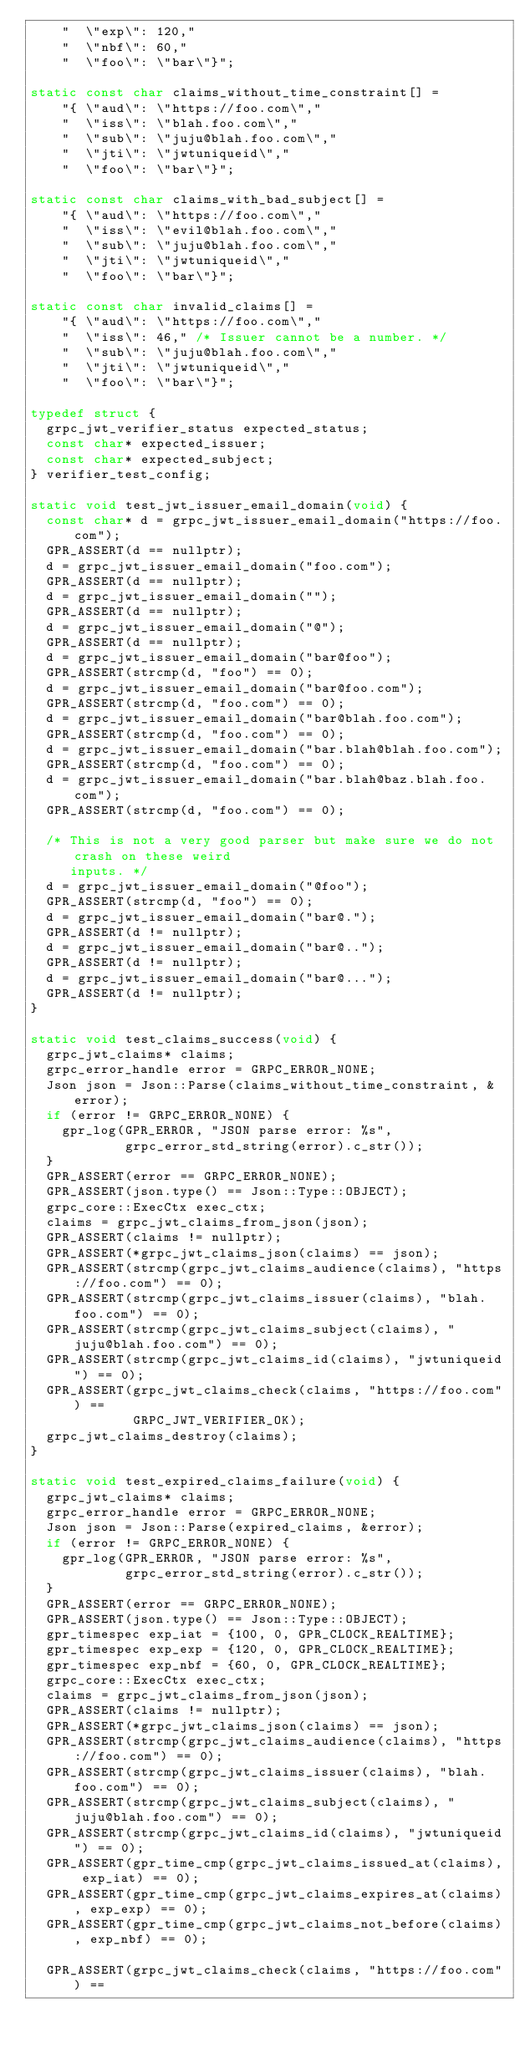<code> <loc_0><loc_0><loc_500><loc_500><_C++_>    "  \"exp\": 120,"
    "  \"nbf\": 60,"
    "  \"foo\": \"bar\"}";

static const char claims_without_time_constraint[] =
    "{ \"aud\": \"https://foo.com\","
    "  \"iss\": \"blah.foo.com\","
    "  \"sub\": \"juju@blah.foo.com\","
    "  \"jti\": \"jwtuniqueid\","
    "  \"foo\": \"bar\"}";

static const char claims_with_bad_subject[] =
    "{ \"aud\": \"https://foo.com\","
    "  \"iss\": \"evil@blah.foo.com\","
    "  \"sub\": \"juju@blah.foo.com\","
    "  \"jti\": \"jwtuniqueid\","
    "  \"foo\": \"bar\"}";

static const char invalid_claims[] =
    "{ \"aud\": \"https://foo.com\","
    "  \"iss\": 46," /* Issuer cannot be a number. */
    "  \"sub\": \"juju@blah.foo.com\","
    "  \"jti\": \"jwtuniqueid\","
    "  \"foo\": \"bar\"}";

typedef struct {
  grpc_jwt_verifier_status expected_status;
  const char* expected_issuer;
  const char* expected_subject;
} verifier_test_config;

static void test_jwt_issuer_email_domain(void) {
  const char* d = grpc_jwt_issuer_email_domain("https://foo.com");
  GPR_ASSERT(d == nullptr);
  d = grpc_jwt_issuer_email_domain("foo.com");
  GPR_ASSERT(d == nullptr);
  d = grpc_jwt_issuer_email_domain("");
  GPR_ASSERT(d == nullptr);
  d = grpc_jwt_issuer_email_domain("@");
  GPR_ASSERT(d == nullptr);
  d = grpc_jwt_issuer_email_domain("bar@foo");
  GPR_ASSERT(strcmp(d, "foo") == 0);
  d = grpc_jwt_issuer_email_domain("bar@foo.com");
  GPR_ASSERT(strcmp(d, "foo.com") == 0);
  d = grpc_jwt_issuer_email_domain("bar@blah.foo.com");
  GPR_ASSERT(strcmp(d, "foo.com") == 0);
  d = grpc_jwt_issuer_email_domain("bar.blah@blah.foo.com");
  GPR_ASSERT(strcmp(d, "foo.com") == 0);
  d = grpc_jwt_issuer_email_domain("bar.blah@baz.blah.foo.com");
  GPR_ASSERT(strcmp(d, "foo.com") == 0);

  /* This is not a very good parser but make sure we do not crash on these weird
     inputs. */
  d = grpc_jwt_issuer_email_domain("@foo");
  GPR_ASSERT(strcmp(d, "foo") == 0);
  d = grpc_jwt_issuer_email_domain("bar@.");
  GPR_ASSERT(d != nullptr);
  d = grpc_jwt_issuer_email_domain("bar@..");
  GPR_ASSERT(d != nullptr);
  d = grpc_jwt_issuer_email_domain("bar@...");
  GPR_ASSERT(d != nullptr);
}

static void test_claims_success(void) {
  grpc_jwt_claims* claims;
  grpc_error_handle error = GRPC_ERROR_NONE;
  Json json = Json::Parse(claims_without_time_constraint, &error);
  if (error != GRPC_ERROR_NONE) {
    gpr_log(GPR_ERROR, "JSON parse error: %s",
            grpc_error_std_string(error).c_str());
  }
  GPR_ASSERT(error == GRPC_ERROR_NONE);
  GPR_ASSERT(json.type() == Json::Type::OBJECT);
  grpc_core::ExecCtx exec_ctx;
  claims = grpc_jwt_claims_from_json(json);
  GPR_ASSERT(claims != nullptr);
  GPR_ASSERT(*grpc_jwt_claims_json(claims) == json);
  GPR_ASSERT(strcmp(grpc_jwt_claims_audience(claims), "https://foo.com") == 0);
  GPR_ASSERT(strcmp(grpc_jwt_claims_issuer(claims), "blah.foo.com") == 0);
  GPR_ASSERT(strcmp(grpc_jwt_claims_subject(claims), "juju@blah.foo.com") == 0);
  GPR_ASSERT(strcmp(grpc_jwt_claims_id(claims), "jwtuniqueid") == 0);
  GPR_ASSERT(grpc_jwt_claims_check(claims, "https://foo.com") ==
             GRPC_JWT_VERIFIER_OK);
  grpc_jwt_claims_destroy(claims);
}

static void test_expired_claims_failure(void) {
  grpc_jwt_claims* claims;
  grpc_error_handle error = GRPC_ERROR_NONE;
  Json json = Json::Parse(expired_claims, &error);
  if (error != GRPC_ERROR_NONE) {
    gpr_log(GPR_ERROR, "JSON parse error: %s",
            grpc_error_std_string(error).c_str());
  }
  GPR_ASSERT(error == GRPC_ERROR_NONE);
  GPR_ASSERT(json.type() == Json::Type::OBJECT);
  gpr_timespec exp_iat = {100, 0, GPR_CLOCK_REALTIME};
  gpr_timespec exp_exp = {120, 0, GPR_CLOCK_REALTIME};
  gpr_timespec exp_nbf = {60, 0, GPR_CLOCK_REALTIME};
  grpc_core::ExecCtx exec_ctx;
  claims = grpc_jwt_claims_from_json(json);
  GPR_ASSERT(claims != nullptr);
  GPR_ASSERT(*grpc_jwt_claims_json(claims) == json);
  GPR_ASSERT(strcmp(grpc_jwt_claims_audience(claims), "https://foo.com") == 0);
  GPR_ASSERT(strcmp(grpc_jwt_claims_issuer(claims), "blah.foo.com") == 0);
  GPR_ASSERT(strcmp(grpc_jwt_claims_subject(claims), "juju@blah.foo.com") == 0);
  GPR_ASSERT(strcmp(grpc_jwt_claims_id(claims), "jwtuniqueid") == 0);
  GPR_ASSERT(gpr_time_cmp(grpc_jwt_claims_issued_at(claims), exp_iat) == 0);
  GPR_ASSERT(gpr_time_cmp(grpc_jwt_claims_expires_at(claims), exp_exp) == 0);
  GPR_ASSERT(gpr_time_cmp(grpc_jwt_claims_not_before(claims), exp_nbf) == 0);

  GPR_ASSERT(grpc_jwt_claims_check(claims, "https://foo.com") ==</code> 